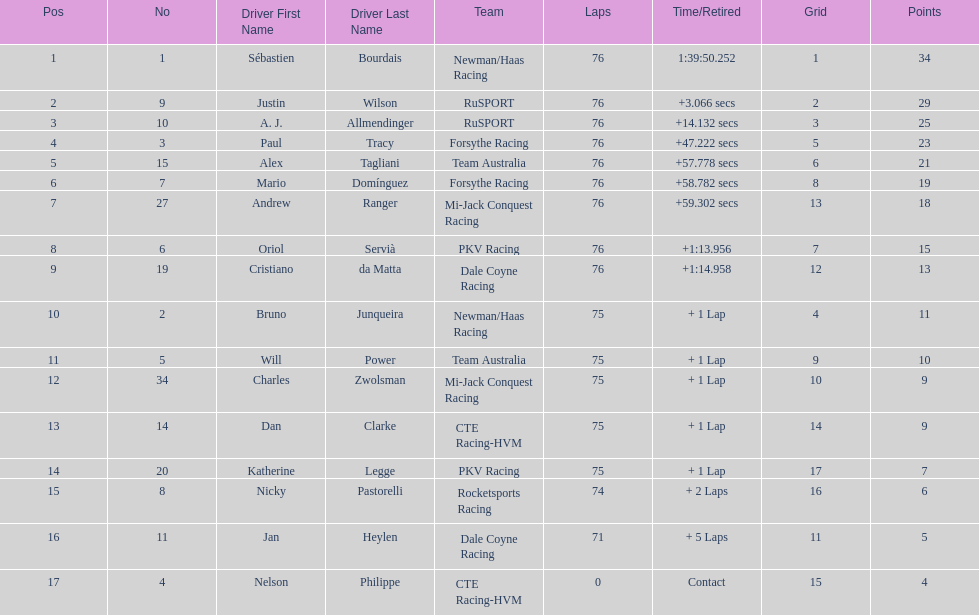What was the total points that canada earned together? 62. 